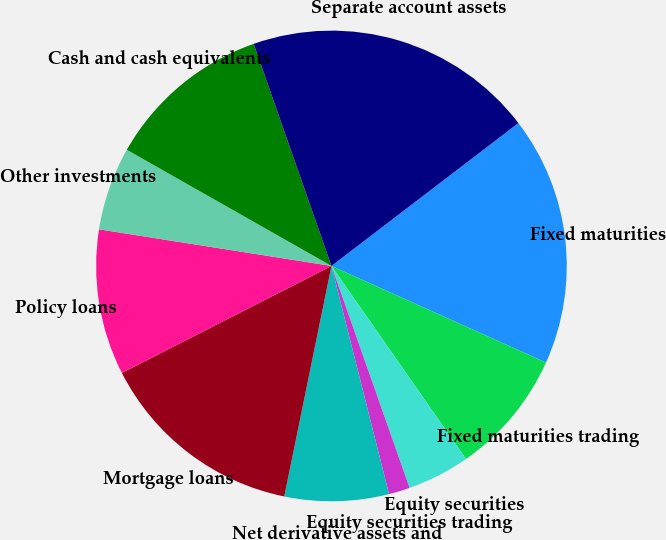Convert chart. <chart><loc_0><loc_0><loc_500><loc_500><pie_chart><fcel>Fixed maturities<fcel>Fixed maturities trading<fcel>Equity securities<fcel>Equity securities trading<fcel>Net derivative assets and<fcel>Mortgage loans<fcel>Policy loans<fcel>Other investments<fcel>Cash and cash equivalents<fcel>Separate account assets<nl><fcel>17.12%<fcel>8.58%<fcel>4.3%<fcel>1.45%<fcel>7.15%<fcel>14.27%<fcel>10.0%<fcel>5.73%<fcel>11.42%<fcel>19.97%<nl></chart> 